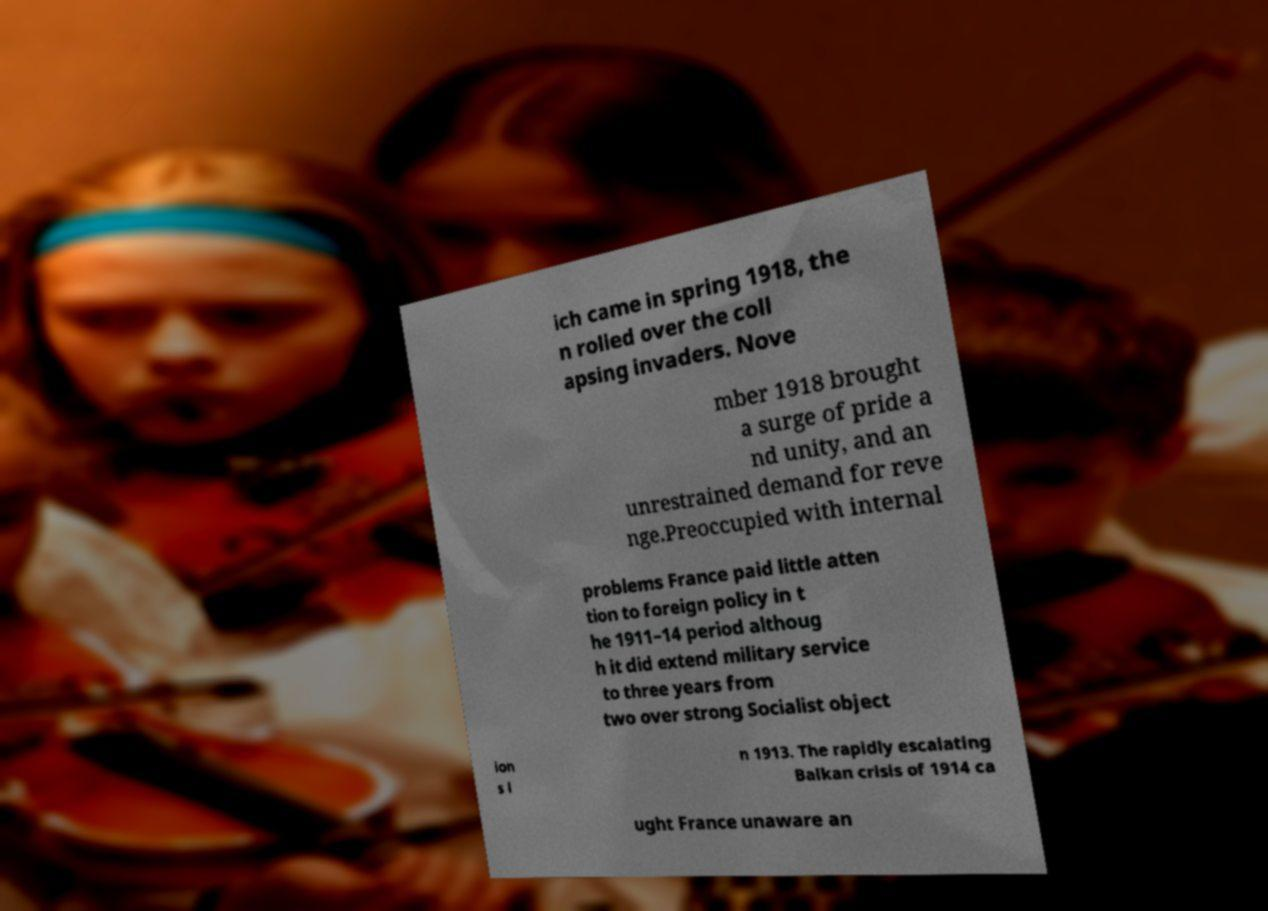What messages or text are displayed in this image? I need them in a readable, typed format. ich came in spring 1918, the n rolled over the coll apsing invaders. Nove mber 1918 brought a surge of pride a nd unity, and an unrestrained demand for reve nge.Preoccupied with internal problems France paid little atten tion to foreign policy in t he 1911–14 period althoug h it did extend military service to three years from two over strong Socialist object ion s i n 1913. The rapidly escalating Balkan crisis of 1914 ca ught France unaware an 